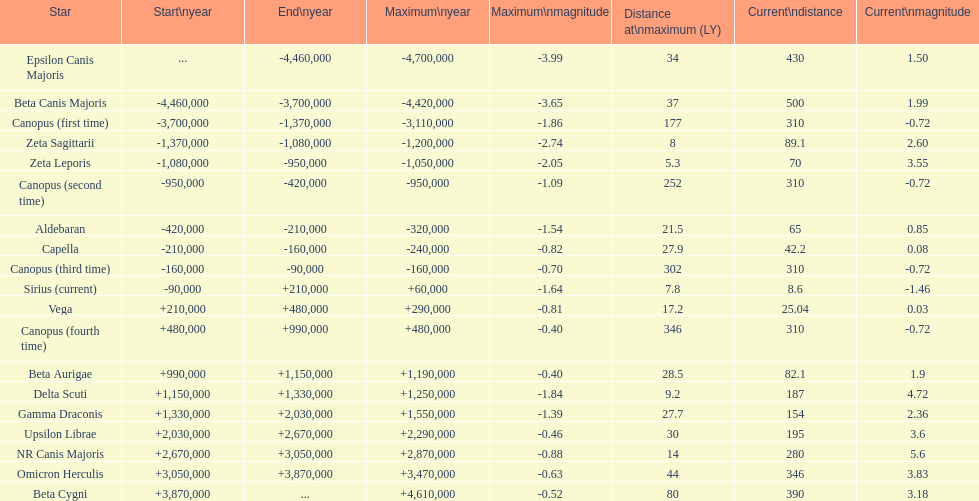Which star has the greatest maximum distance? Canopus (fourth time). 